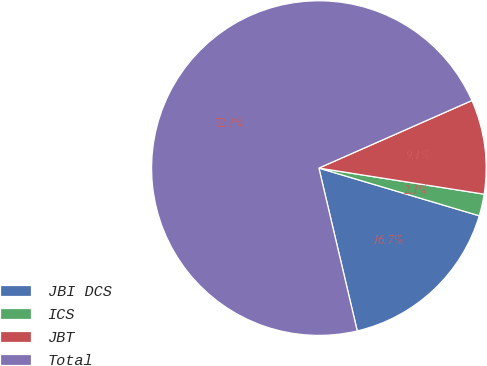Convert chart to OTSL. <chart><loc_0><loc_0><loc_500><loc_500><pie_chart><fcel>JBI DCS<fcel>ICS<fcel>JBT<fcel>Total<nl><fcel>16.72%<fcel>2.11%<fcel>9.11%<fcel>72.07%<nl></chart> 